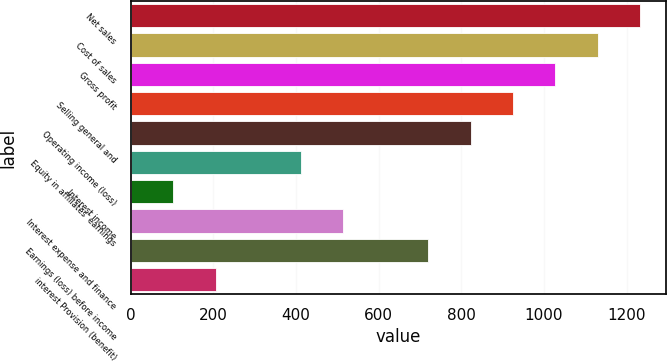Convert chart to OTSL. <chart><loc_0><loc_0><loc_500><loc_500><bar_chart><fcel>Net sales<fcel>Cost of sales<fcel>Gross profit<fcel>Selling general and<fcel>Operating income (loss)<fcel>Equity in affiliates' earnings<fcel>Interest income<fcel>Interest expense and finance<fcel>Earnings (loss) before income<fcel>interest Provision (benefit)<nl><fcel>1233.32<fcel>1130.55<fcel>1027.78<fcel>925.01<fcel>822.25<fcel>411.19<fcel>102.91<fcel>513.95<fcel>719.49<fcel>205.67<nl></chart> 